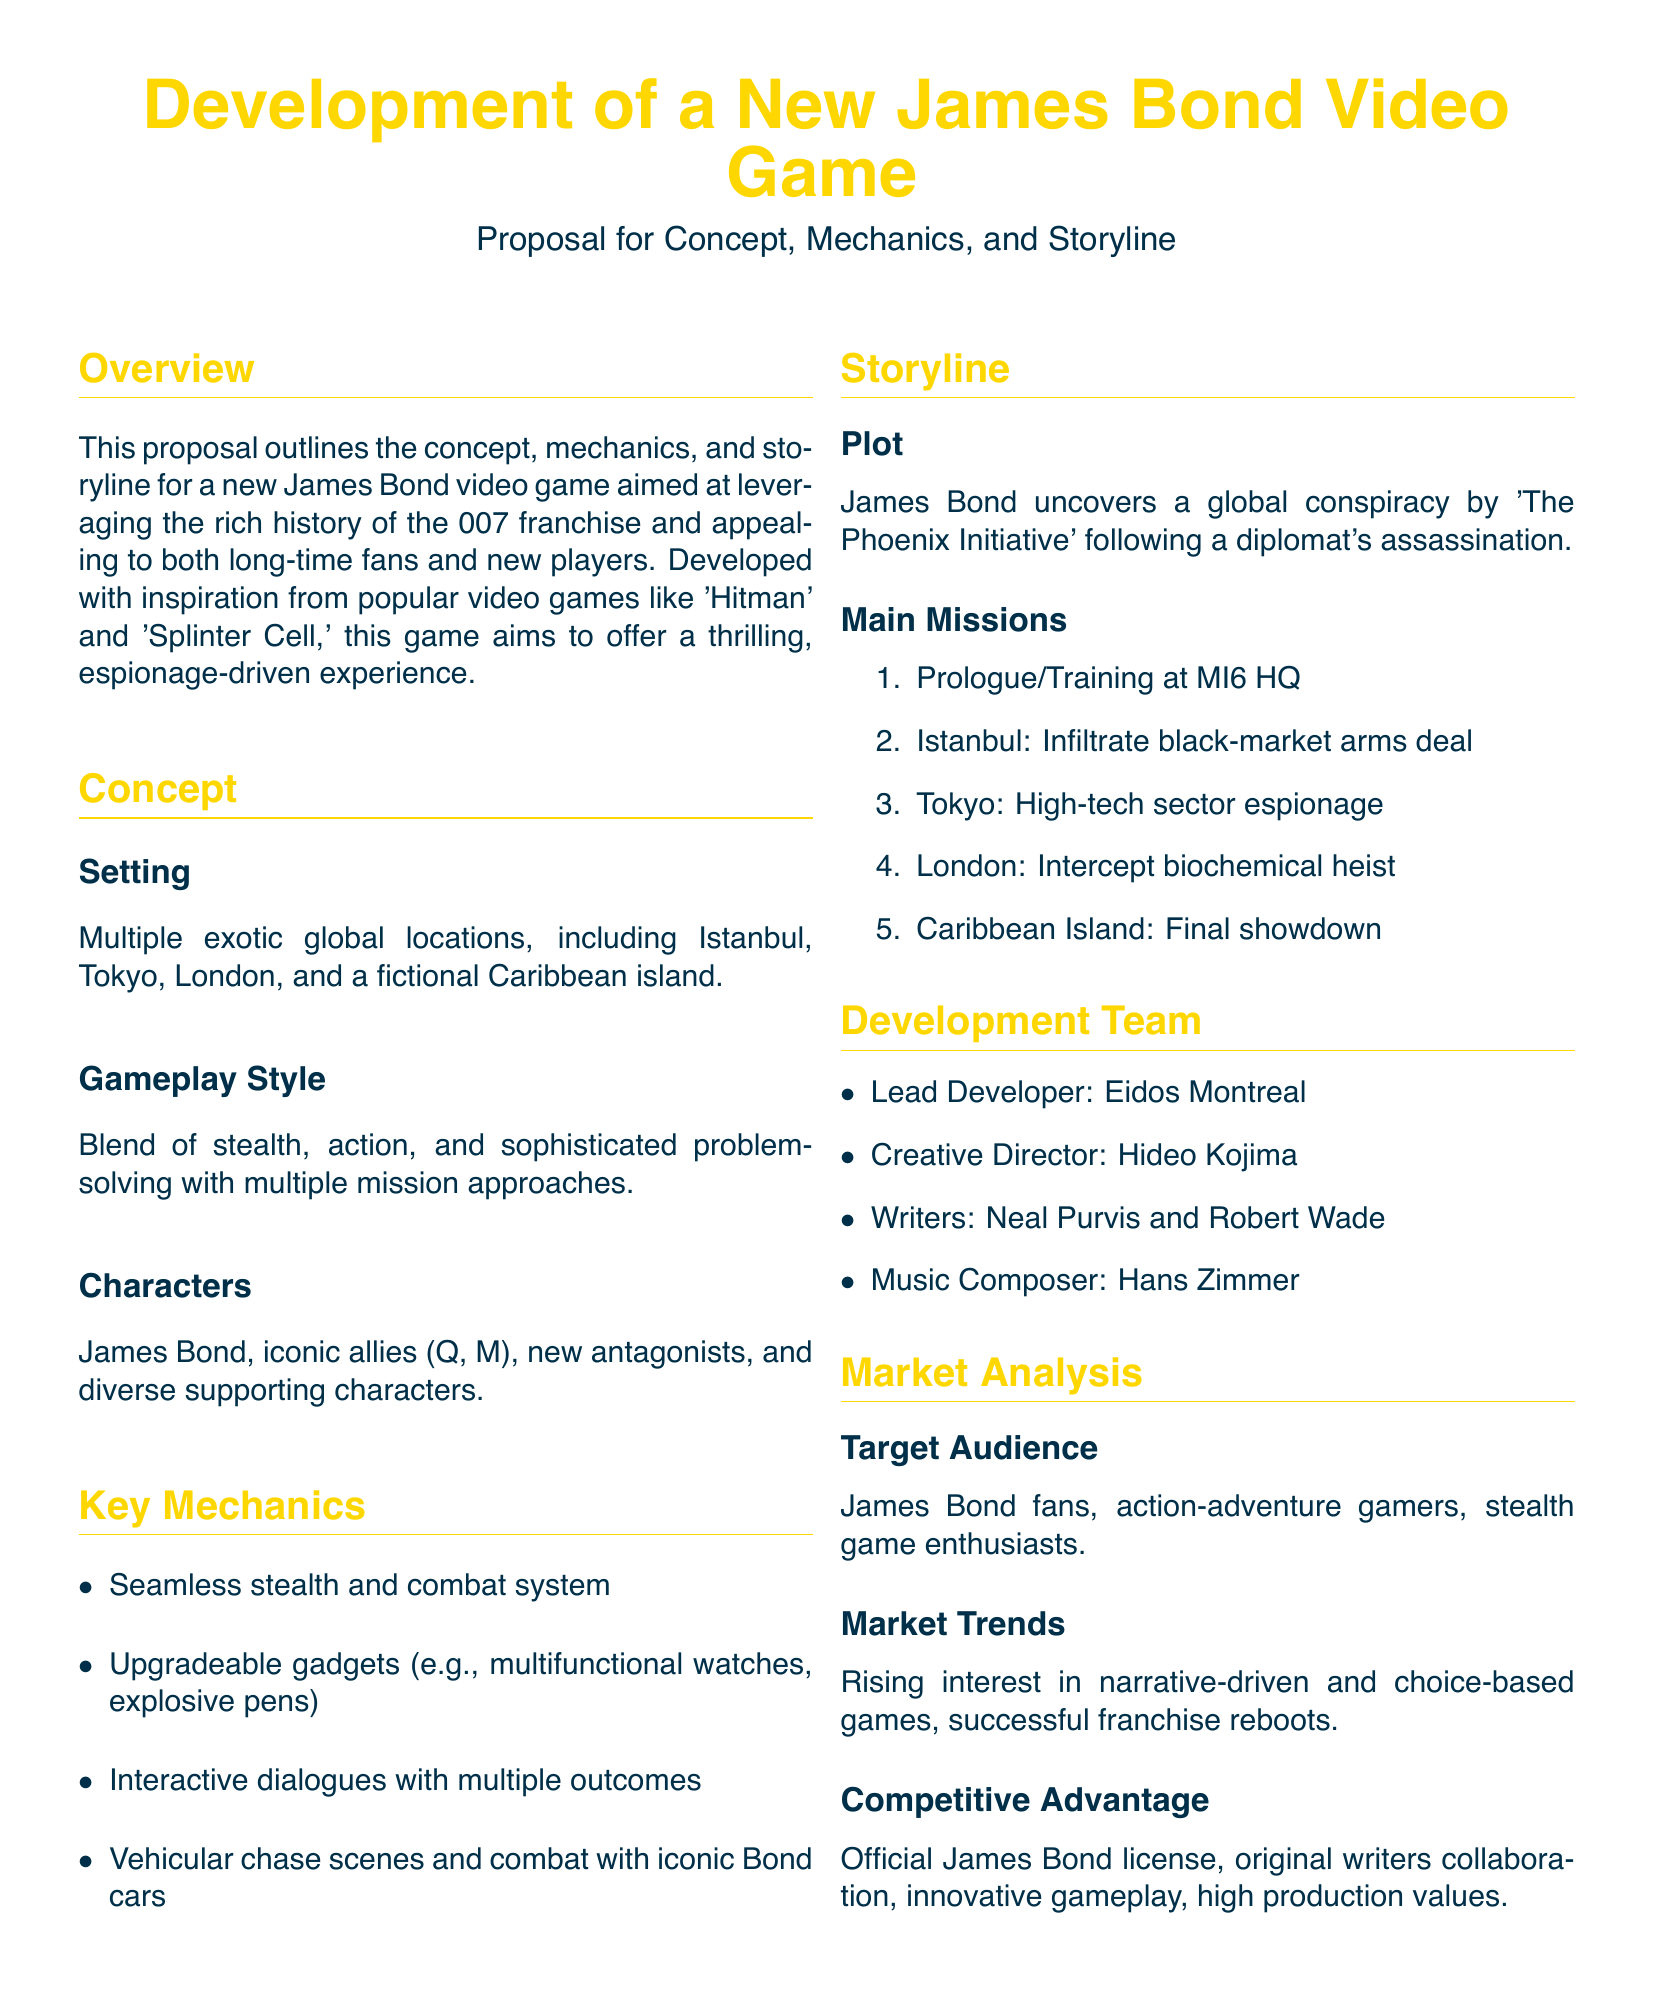What is the main character in the game? The main character is identified in the proposal, focusing on the iconic figure of the franchise.
Answer: James Bond Who is the creative director of the game? The creative director is a significant role mentioned in the development team section of the proposal.
Answer: Hideo Kojima What is the setting of the new game? The proposal outlines various exotic locations serving as key settings for missions.
Answer: Istanbul, Tokyo, London, Caribbean Island How many main missions are listed in the storyline? The total number of listed missions is calculated from the enumerated points provided in the document.
Answer: Five What kind of gameplay style is described in the proposal? The gameplay style is explained in terms of its diverse elements, indicating a blend of approaches.
Answer: Stealth, action, problem-solving Which composer is mentioned for the game’s music? The music composer noted in the proposal highlights a recognizable figure in the industry.
Answer: Hans Zimmer What main initiative poses a global conspiracy in the storyline? The main initiative that Bond is investigating is specified in the plot section of the proposal.
Answer: The Phoenix Initiative Which company is the lead developer? The lead developer is a key player in the development section of the proposal.
Answer: Eidos Montreal 